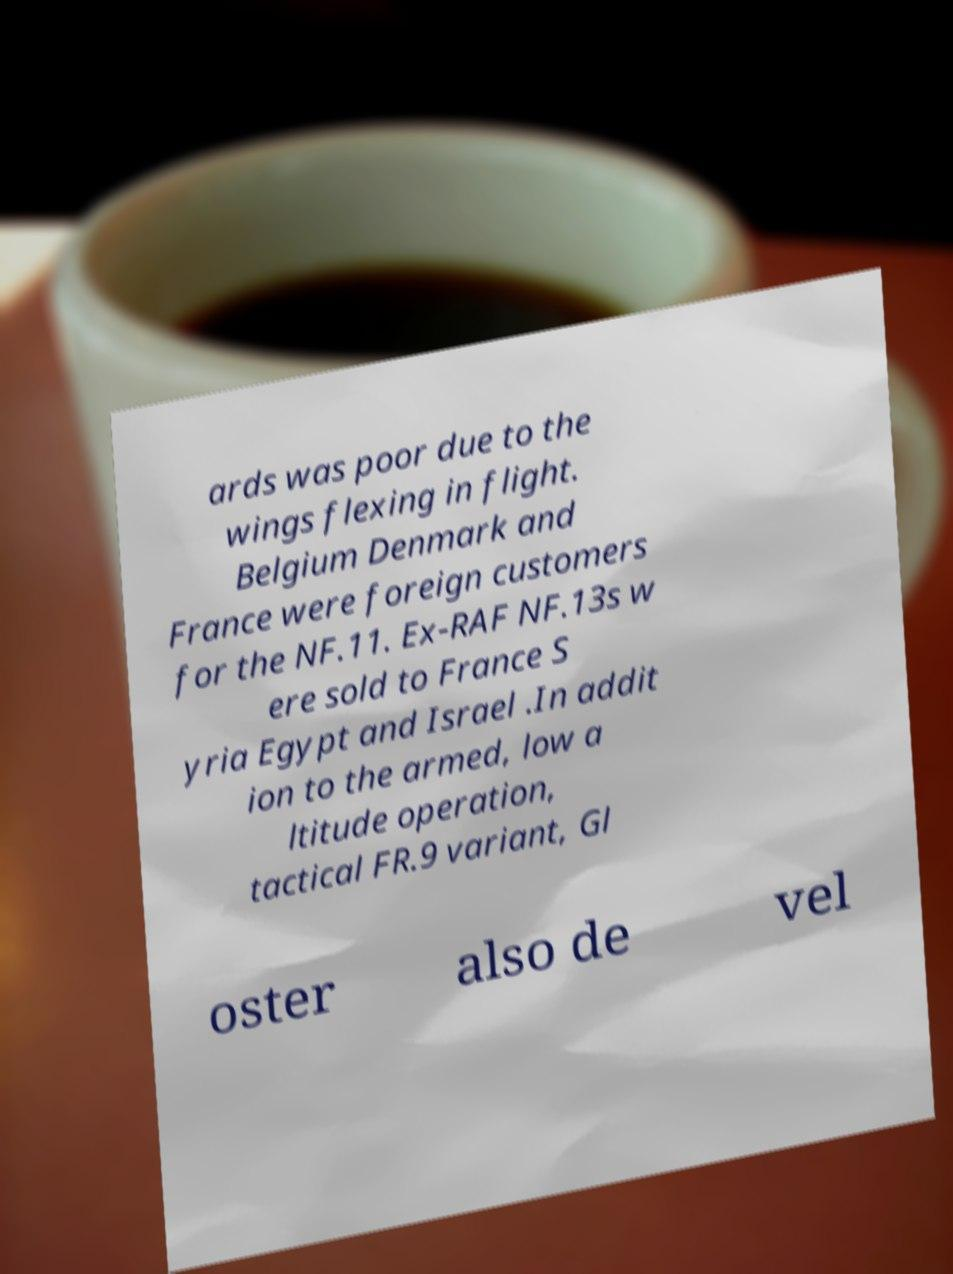For documentation purposes, I need the text within this image transcribed. Could you provide that? ards was poor due to the wings flexing in flight. Belgium Denmark and France were foreign customers for the NF.11. Ex-RAF NF.13s w ere sold to France S yria Egypt and Israel .In addit ion to the armed, low a ltitude operation, tactical FR.9 variant, Gl oster also de vel 